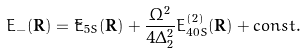Convert formula to latex. <formula><loc_0><loc_0><loc_500><loc_500>E _ { - } ( \mathbf R ) = \tilde { E } _ { 5 S } ( \mathbf R ) + \frac { \Omega ^ { 2 } } { 4 \Delta _ { 2 } ^ { 2 } } E _ { 4 0 S } ^ { ( 2 ) } ( \mathbf R ) + c o n s t .</formula> 